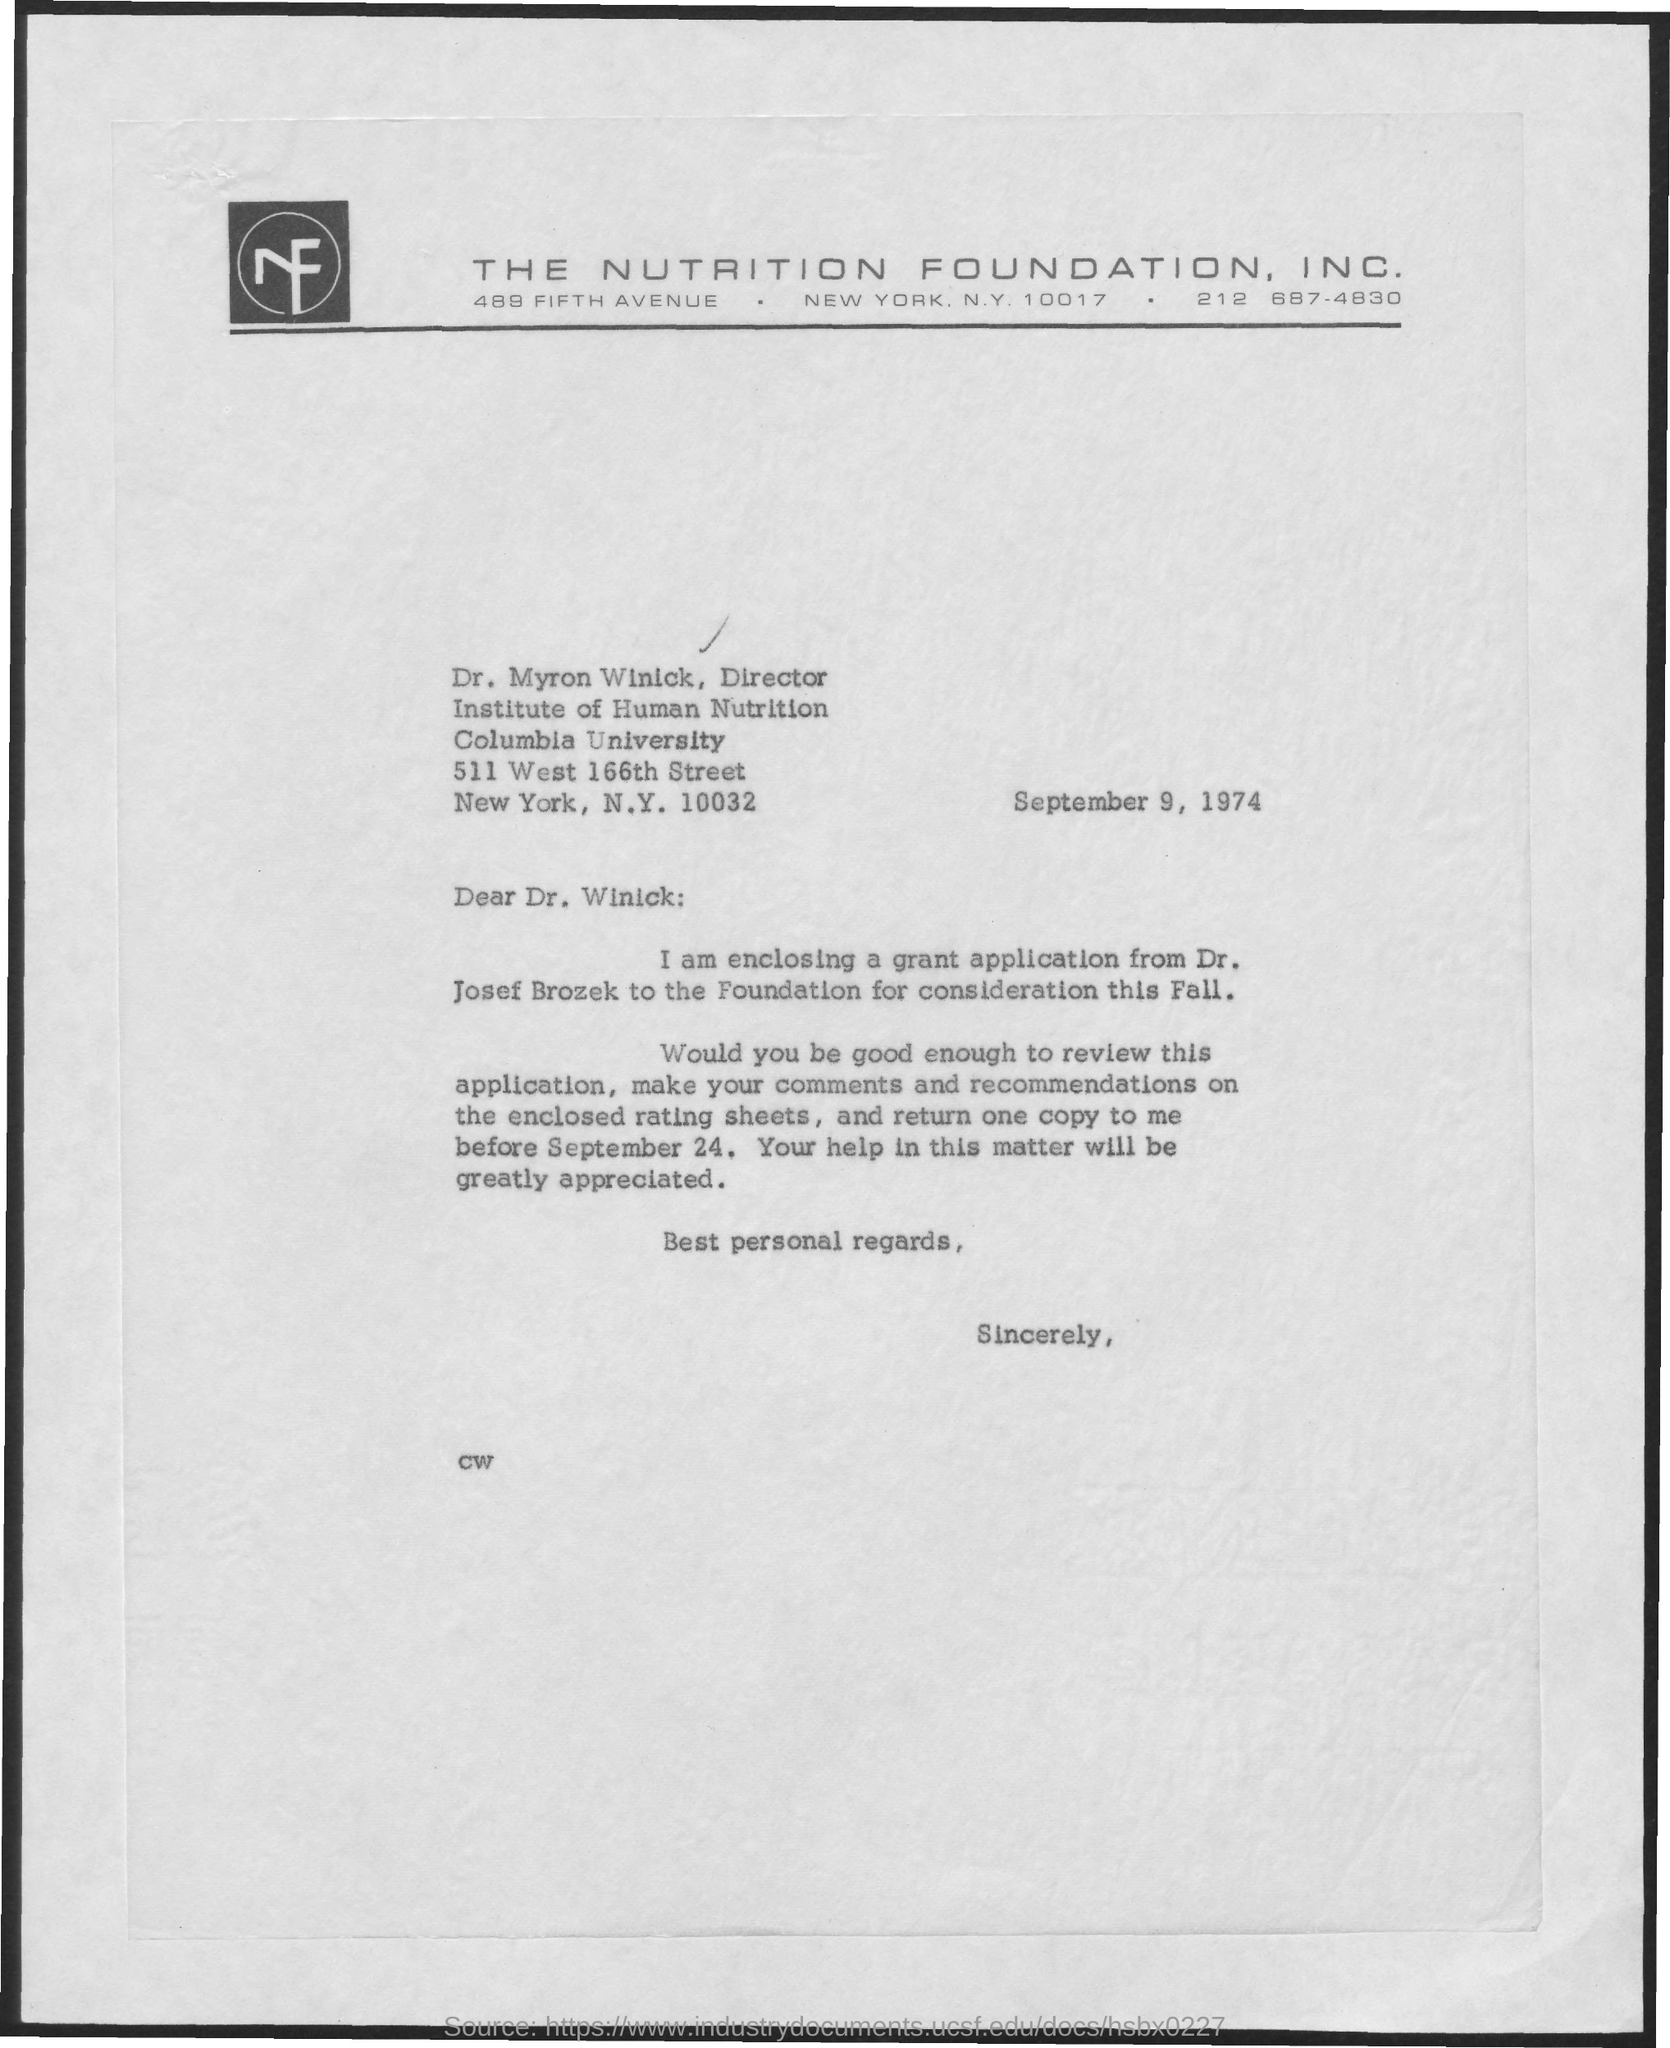What is the date on the document?
Ensure brevity in your answer.  September 9, 1974. Whose application is enclosed?
Give a very brief answer. Dr. Josef Brozek. 